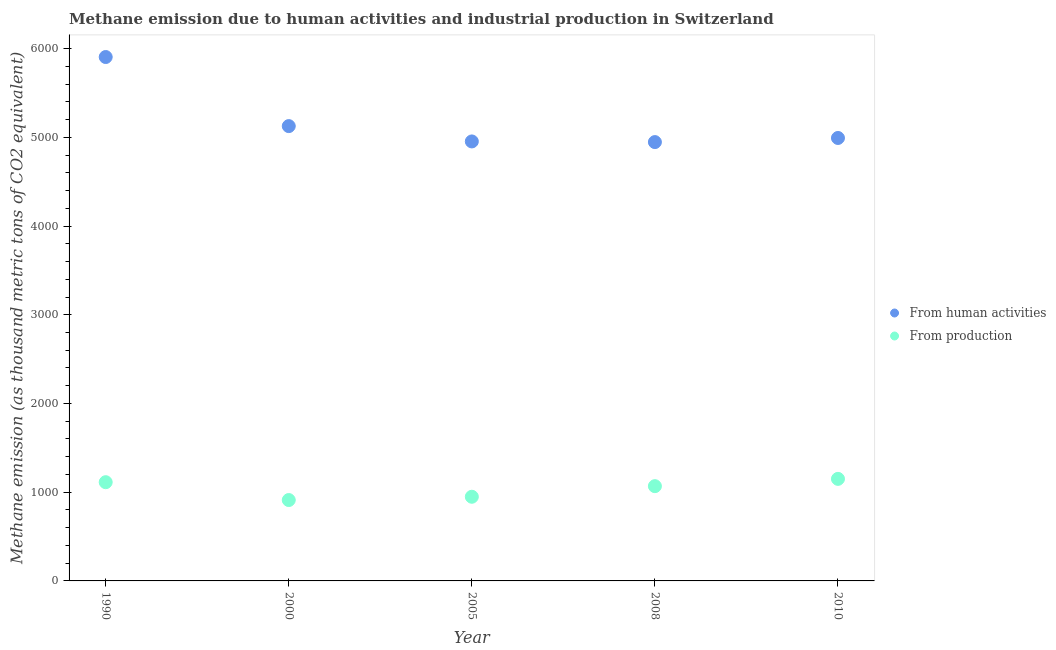How many different coloured dotlines are there?
Make the answer very short. 2. What is the amount of emissions from human activities in 2010?
Provide a short and direct response. 4992.4. Across all years, what is the maximum amount of emissions from human activities?
Provide a short and direct response. 5904.8. Across all years, what is the minimum amount of emissions generated from industries?
Your answer should be compact. 911.6. In which year was the amount of emissions generated from industries maximum?
Your answer should be very brief. 2010. What is the total amount of emissions from human activities in the graph?
Offer a very short reply. 2.59e+04. What is the difference between the amount of emissions from human activities in 1990 and that in 2008?
Provide a short and direct response. 958.7. What is the difference between the amount of emissions from human activities in 2000 and the amount of emissions generated from industries in 2005?
Your response must be concise. 4177.6. What is the average amount of emissions generated from industries per year?
Make the answer very short. 1038.24. In the year 2005, what is the difference between the amount of emissions from human activities and amount of emissions generated from industries?
Provide a short and direct response. 4004.8. What is the ratio of the amount of emissions generated from industries in 1990 to that in 2008?
Offer a terse response. 1.04. Is the amount of emissions from human activities in 1990 less than that in 2010?
Your response must be concise. No. What is the difference between the highest and the second highest amount of emissions from human activities?
Provide a short and direct response. 778.6. What is the difference between the highest and the lowest amount of emissions generated from industries?
Offer a very short reply. 238.6. Is the amount of emissions generated from industries strictly greater than the amount of emissions from human activities over the years?
Make the answer very short. No. How many years are there in the graph?
Your response must be concise. 5. Does the graph contain any zero values?
Offer a very short reply. No. Does the graph contain grids?
Provide a short and direct response. No. Where does the legend appear in the graph?
Your response must be concise. Center right. How many legend labels are there?
Make the answer very short. 2. What is the title of the graph?
Give a very brief answer. Methane emission due to human activities and industrial production in Switzerland. Does "Merchandise imports" appear as one of the legend labels in the graph?
Your answer should be compact. No. What is the label or title of the X-axis?
Offer a terse response. Year. What is the label or title of the Y-axis?
Make the answer very short. Methane emission (as thousand metric tons of CO2 equivalent). What is the Methane emission (as thousand metric tons of CO2 equivalent) of From human activities in 1990?
Make the answer very short. 5904.8. What is the Methane emission (as thousand metric tons of CO2 equivalent) of From production in 1990?
Keep it short and to the point. 1112.7. What is the Methane emission (as thousand metric tons of CO2 equivalent) in From human activities in 2000?
Your response must be concise. 5126.2. What is the Methane emission (as thousand metric tons of CO2 equivalent) in From production in 2000?
Keep it short and to the point. 911.6. What is the Methane emission (as thousand metric tons of CO2 equivalent) in From human activities in 2005?
Offer a very short reply. 4953.4. What is the Methane emission (as thousand metric tons of CO2 equivalent) in From production in 2005?
Provide a short and direct response. 948.6. What is the Methane emission (as thousand metric tons of CO2 equivalent) in From human activities in 2008?
Provide a succinct answer. 4946.1. What is the Methane emission (as thousand metric tons of CO2 equivalent) in From production in 2008?
Ensure brevity in your answer.  1068.1. What is the Methane emission (as thousand metric tons of CO2 equivalent) of From human activities in 2010?
Provide a short and direct response. 4992.4. What is the Methane emission (as thousand metric tons of CO2 equivalent) of From production in 2010?
Keep it short and to the point. 1150.2. Across all years, what is the maximum Methane emission (as thousand metric tons of CO2 equivalent) in From human activities?
Your answer should be compact. 5904.8. Across all years, what is the maximum Methane emission (as thousand metric tons of CO2 equivalent) of From production?
Your answer should be compact. 1150.2. Across all years, what is the minimum Methane emission (as thousand metric tons of CO2 equivalent) of From human activities?
Offer a terse response. 4946.1. Across all years, what is the minimum Methane emission (as thousand metric tons of CO2 equivalent) in From production?
Ensure brevity in your answer.  911.6. What is the total Methane emission (as thousand metric tons of CO2 equivalent) of From human activities in the graph?
Offer a very short reply. 2.59e+04. What is the total Methane emission (as thousand metric tons of CO2 equivalent) in From production in the graph?
Offer a very short reply. 5191.2. What is the difference between the Methane emission (as thousand metric tons of CO2 equivalent) in From human activities in 1990 and that in 2000?
Your answer should be compact. 778.6. What is the difference between the Methane emission (as thousand metric tons of CO2 equivalent) in From production in 1990 and that in 2000?
Offer a very short reply. 201.1. What is the difference between the Methane emission (as thousand metric tons of CO2 equivalent) of From human activities in 1990 and that in 2005?
Make the answer very short. 951.4. What is the difference between the Methane emission (as thousand metric tons of CO2 equivalent) in From production in 1990 and that in 2005?
Provide a succinct answer. 164.1. What is the difference between the Methane emission (as thousand metric tons of CO2 equivalent) in From human activities in 1990 and that in 2008?
Your answer should be very brief. 958.7. What is the difference between the Methane emission (as thousand metric tons of CO2 equivalent) of From production in 1990 and that in 2008?
Your answer should be very brief. 44.6. What is the difference between the Methane emission (as thousand metric tons of CO2 equivalent) of From human activities in 1990 and that in 2010?
Keep it short and to the point. 912.4. What is the difference between the Methane emission (as thousand metric tons of CO2 equivalent) in From production in 1990 and that in 2010?
Make the answer very short. -37.5. What is the difference between the Methane emission (as thousand metric tons of CO2 equivalent) of From human activities in 2000 and that in 2005?
Give a very brief answer. 172.8. What is the difference between the Methane emission (as thousand metric tons of CO2 equivalent) of From production in 2000 and that in 2005?
Keep it short and to the point. -37. What is the difference between the Methane emission (as thousand metric tons of CO2 equivalent) of From human activities in 2000 and that in 2008?
Offer a very short reply. 180.1. What is the difference between the Methane emission (as thousand metric tons of CO2 equivalent) of From production in 2000 and that in 2008?
Your answer should be compact. -156.5. What is the difference between the Methane emission (as thousand metric tons of CO2 equivalent) of From human activities in 2000 and that in 2010?
Offer a terse response. 133.8. What is the difference between the Methane emission (as thousand metric tons of CO2 equivalent) of From production in 2000 and that in 2010?
Ensure brevity in your answer.  -238.6. What is the difference between the Methane emission (as thousand metric tons of CO2 equivalent) of From production in 2005 and that in 2008?
Your answer should be very brief. -119.5. What is the difference between the Methane emission (as thousand metric tons of CO2 equivalent) in From human activities in 2005 and that in 2010?
Provide a short and direct response. -39. What is the difference between the Methane emission (as thousand metric tons of CO2 equivalent) of From production in 2005 and that in 2010?
Keep it short and to the point. -201.6. What is the difference between the Methane emission (as thousand metric tons of CO2 equivalent) in From human activities in 2008 and that in 2010?
Make the answer very short. -46.3. What is the difference between the Methane emission (as thousand metric tons of CO2 equivalent) of From production in 2008 and that in 2010?
Provide a succinct answer. -82.1. What is the difference between the Methane emission (as thousand metric tons of CO2 equivalent) in From human activities in 1990 and the Methane emission (as thousand metric tons of CO2 equivalent) in From production in 2000?
Offer a very short reply. 4993.2. What is the difference between the Methane emission (as thousand metric tons of CO2 equivalent) of From human activities in 1990 and the Methane emission (as thousand metric tons of CO2 equivalent) of From production in 2005?
Provide a succinct answer. 4956.2. What is the difference between the Methane emission (as thousand metric tons of CO2 equivalent) in From human activities in 1990 and the Methane emission (as thousand metric tons of CO2 equivalent) in From production in 2008?
Provide a succinct answer. 4836.7. What is the difference between the Methane emission (as thousand metric tons of CO2 equivalent) in From human activities in 1990 and the Methane emission (as thousand metric tons of CO2 equivalent) in From production in 2010?
Offer a very short reply. 4754.6. What is the difference between the Methane emission (as thousand metric tons of CO2 equivalent) of From human activities in 2000 and the Methane emission (as thousand metric tons of CO2 equivalent) of From production in 2005?
Ensure brevity in your answer.  4177.6. What is the difference between the Methane emission (as thousand metric tons of CO2 equivalent) of From human activities in 2000 and the Methane emission (as thousand metric tons of CO2 equivalent) of From production in 2008?
Ensure brevity in your answer.  4058.1. What is the difference between the Methane emission (as thousand metric tons of CO2 equivalent) in From human activities in 2000 and the Methane emission (as thousand metric tons of CO2 equivalent) in From production in 2010?
Your response must be concise. 3976. What is the difference between the Methane emission (as thousand metric tons of CO2 equivalent) in From human activities in 2005 and the Methane emission (as thousand metric tons of CO2 equivalent) in From production in 2008?
Offer a terse response. 3885.3. What is the difference between the Methane emission (as thousand metric tons of CO2 equivalent) of From human activities in 2005 and the Methane emission (as thousand metric tons of CO2 equivalent) of From production in 2010?
Ensure brevity in your answer.  3803.2. What is the difference between the Methane emission (as thousand metric tons of CO2 equivalent) in From human activities in 2008 and the Methane emission (as thousand metric tons of CO2 equivalent) in From production in 2010?
Make the answer very short. 3795.9. What is the average Methane emission (as thousand metric tons of CO2 equivalent) in From human activities per year?
Give a very brief answer. 5184.58. What is the average Methane emission (as thousand metric tons of CO2 equivalent) in From production per year?
Your answer should be very brief. 1038.24. In the year 1990, what is the difference between the Methane emission (as thousand metric tons of CO2 equivalent) of From human activities and Methane emission (as thousand metric tons of CO2 equivalent) of From production?
Ensure brevity in your answer.  4792.1. In the year 2000, what is the difference between the Methane emission (as thousand metric tons of CO2 equivalent) of From human activities and Methane emission (as thousand metric tons of CO2 equivalent) of From production?
Offer a terse response. 4214.6. In the year 2005, what is the difference between the Methane emission (as thousand metric tons of CO2 equivalent) in From human activities and Methane emission (as thousand metric tons of CO2 equivalent) in From production?
Provide a short and direct response. 4004.8. In the year 2008, what is the difference between the Methane emission (as thousand metric tons of CO2 equivalent) in From human activities and Methane emission (as thousand metric tons of CO2 equivalent) in From production?
Make the answer very short. 3878. In the year 2010, what is the difference between the Methane emission (as thousand metric tons of CO2 equivalent) of From human activities and Methane emission (as thousand metric tons of CO2 equivalent) of From production?
Your answer should be very brief. 3842.2. What is the ratio of the Methane emission (as thousand metric tons of CO2 equivalent) of From human activities in 1990 to that in 2000?
Offer a terse response. 1.15. What is the ratio of the Methane emission (as thousand metric tons of CO2 equivalent) of From production in 1990 to that in 2000?
Make the answer very short. 1.22. What is the ratio of the Methane emission (as thousand metric tons of CO2 equivalent) of From human activities in 1990 to that in 2005?
Keep it short and to the point. 1.19. What is the ratio of the Methane emission (as thousand metric tons of CO2 equivalent) in From production in 1990 to that in 2005?
Ensure brevity in your answer.  1.17. What is the ratio of the Methane emission (as thousand metric tons of CO2 equivalent) in From human activities in 1990 to that in 2008?
Make the answer very short. 1.19. What is the ratio of the Methane emission (as thousand metric tons of CO2 equivalent) of From production in 1990 to that in 2008?
Your response must be concise. 1.04. What is the ratio of the Methane emission (as thousand metric tons of CO2 equivalent) of From human activities in 1990 to that in 2010?
Keep it short and to the point. 1.18. What is the ratio of the Methane emission (as thousand metric tons of CO2 equivalent) of From production in 1990 to that in 2010?
Provide a short and direct response. 0.97. What is the ratio of the Methane emission (as thousand metric tons of CO2 equivalent) in From human activities in 2000 to that in 2005?
Provide a short and direct response. 1.03. What is the ratio of the Methane emission (as thousand metric tons of CO2 equivalent) in From human activities in 2000 to that in 2008?
Keep it short and to the point. 1.04. What is the ratio of the Methane emission (as thousand metric tons of CO2 equivalent) in From production in 2000 to that in 2008?
Provide a succinct answer. 0.85. What is the ratio of the Methane emission (as thousand metric tons of CO2 equivalent) of From human activities in 2000 to that in 2010?
Make the answer very short. 1.03. What is the ratio of the Methane emission (as thousand metric tons of CO2 equivalent) of From production in 2000 to that in 2010?
Your answer should be very brief. 0.79. What is the ratio of the Methane emission (as thousand metric tons of CO2 equivalent) of From production in 2005 to that in 2008?
Provide a short and direct response. 0.89. What is the ratio of the Methane emission (as thousand metric tons of CO2 equivalent) of From human activities in 2005 to that in 2010?
Your answer should be very brief. 0.99. What is the ratio of the Methane emission (as thousand metric tons of CO2 equivalent) of From production in 2005 to that in 2010?
Your answer should be very brief. 0.82. What is the ratio of the Methane emission (as thousand metric tons of CO2 equivalent) in From human activities in 2008 to that in 2010?
Offer a very short reply. 0.99. What is the difference between the highest and the second highest Methane emission (as thousand metric tons of CO2 equivalent) of From human activities?
Keep it short and to the point. 778.6. What is the difference between the highest and the second highest Methane emission (as thousand metric tons of CO2 equivalent) of From production?
Keep it short and to the point. 37.5. What is the difference between the highest and the lowest Methane emission (as thousand metric tons of CO2 equivalent) in From human activities?
Ensure brevity in your answer.  958.7. What is the difference between the highest and the lowest Methane emission (as thousand metric tons of CO2 equivalent) of From production?
Provide a succinct answer. 238.6. 